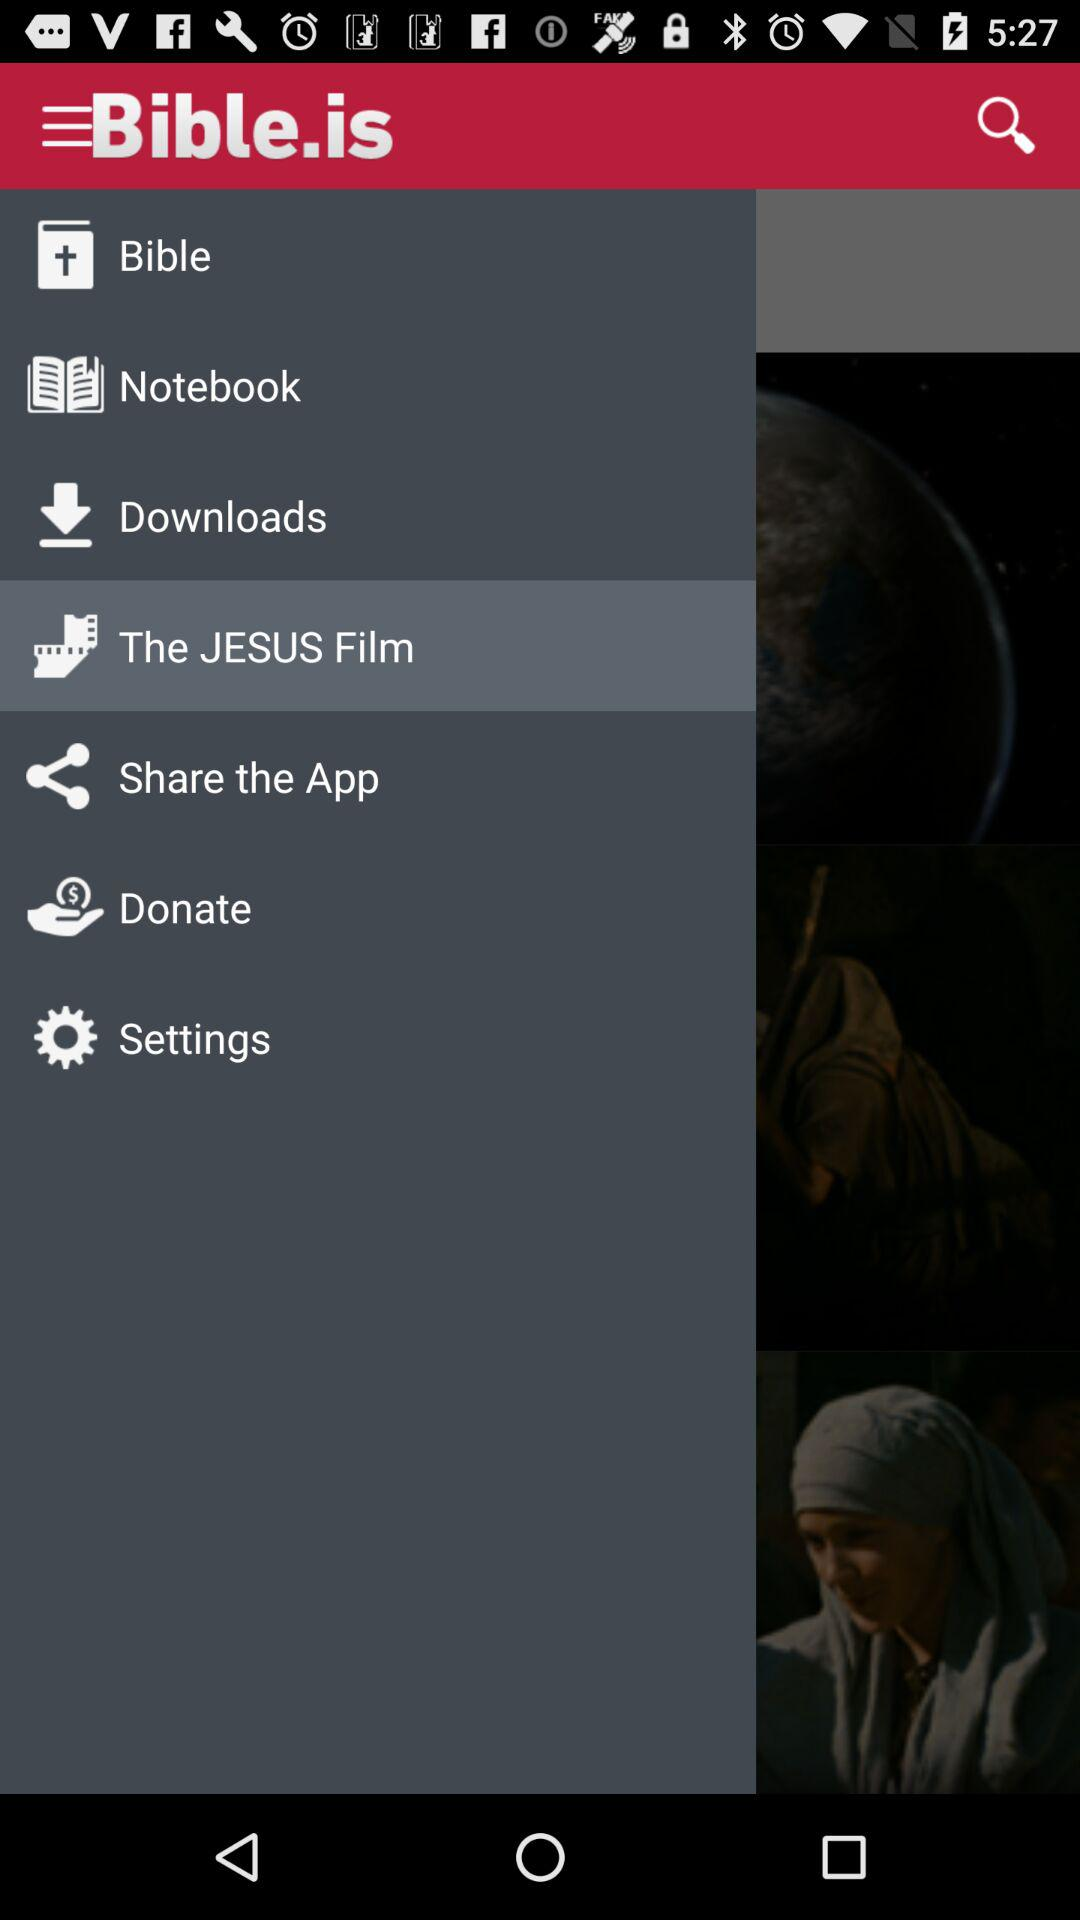What is the name of the application? The application name is "Bible.is". 